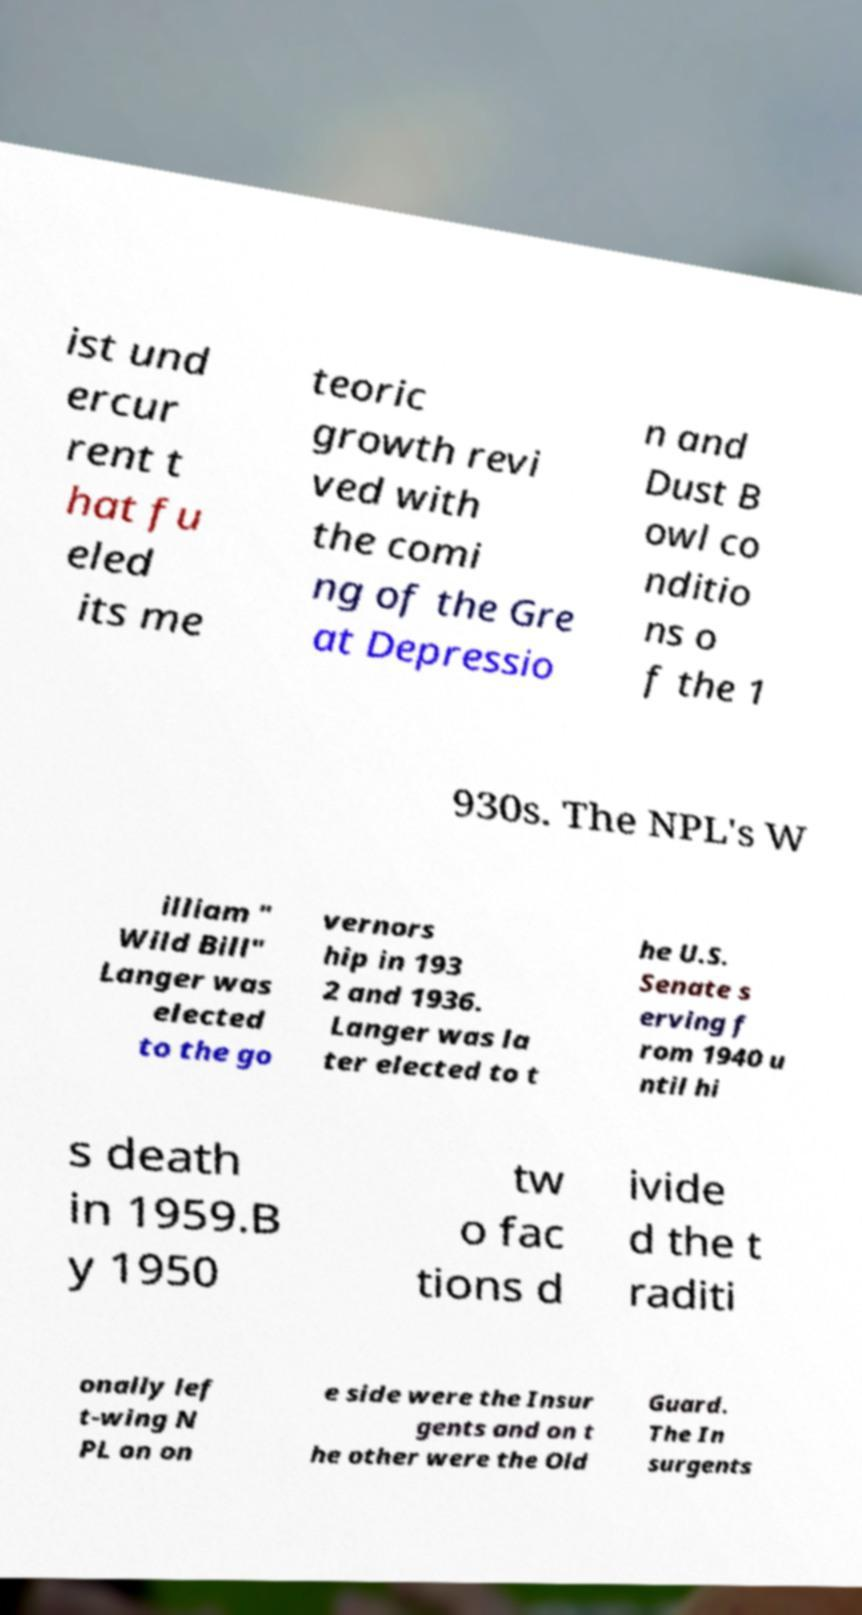What messages or text are displayed in this image? I need them in a readable, typed format. ist und ercur rent t hat fu eled its me teoric growth revi ved with the comi ng of the Gre at Depressio n and Dust B owl co nditio ns o f the 1 930s. The NPL's W illiam " Wild Bill" Langer was elected to the go vernors hip in 193 2 and 1936. Langer was la ter elected to t he U.S. Senate s erving f rom 1940 u ntil hi s death in 1959.B y 1950 tw o fac tions d ivide d the t raditi onally lef t-wing N PL on on e side were the Insur gents and on t he other were the Old Guard. The In surgents 